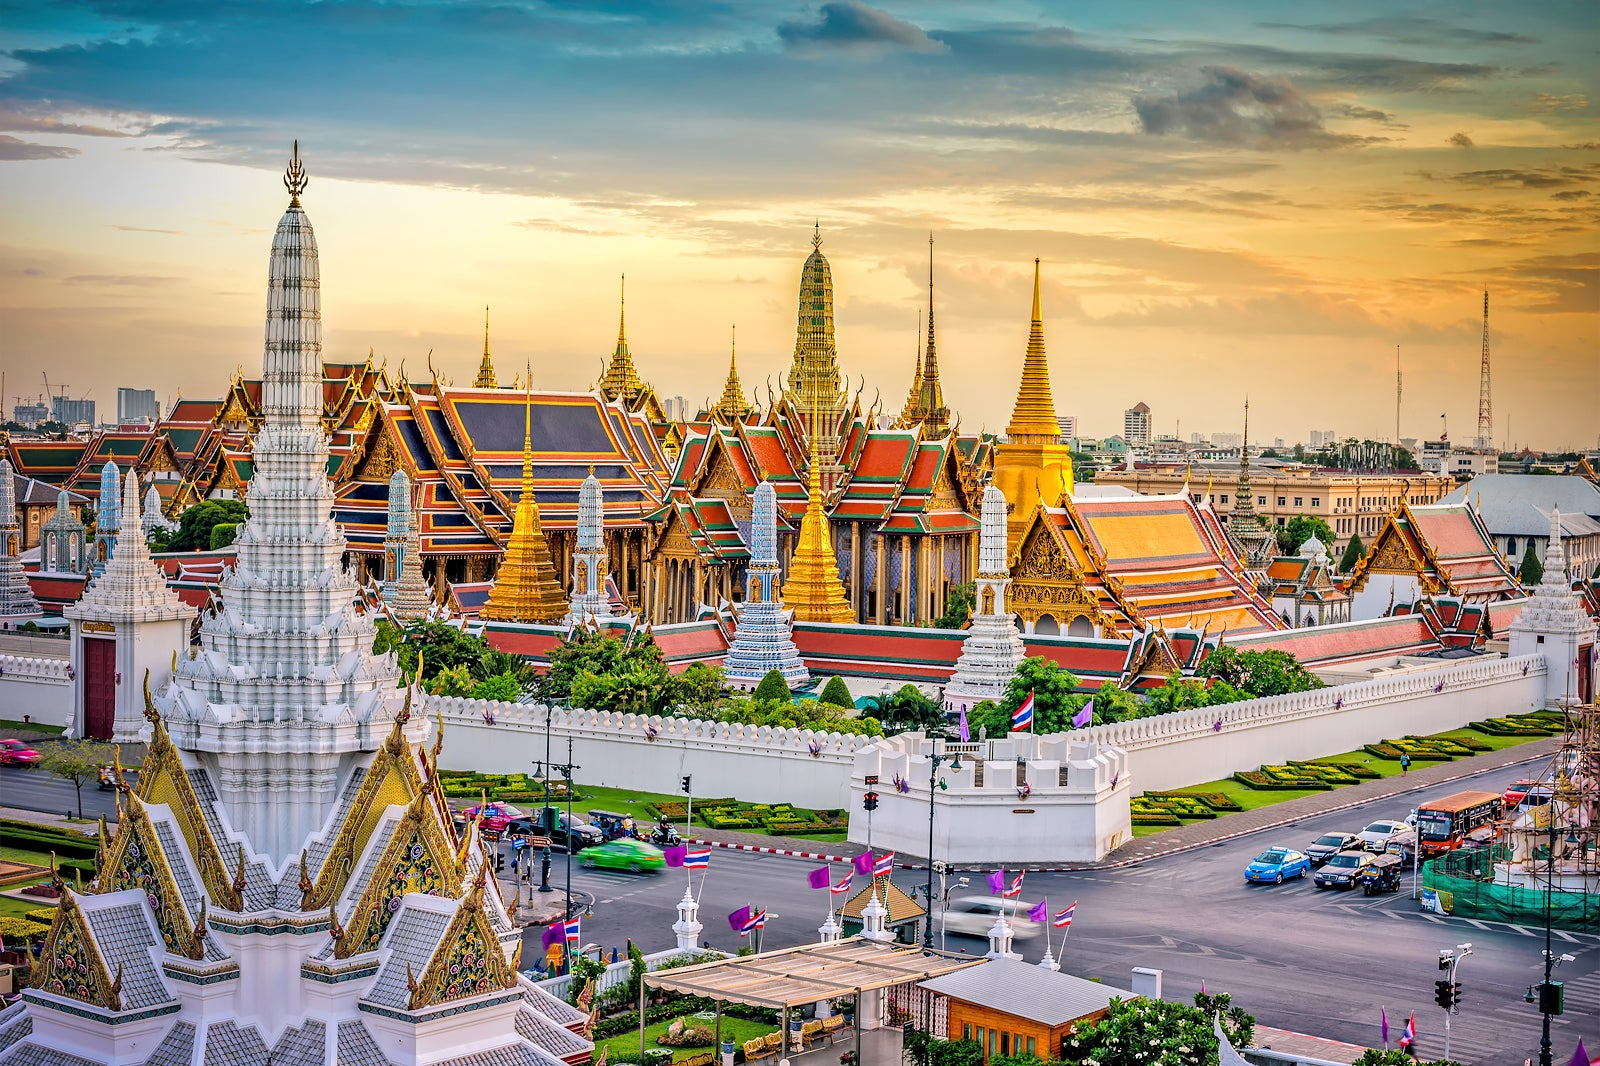Describe the intricate designs on the palace structures. The intricate designs on the palace structures are a testament to traditional Thai craftsmanship. The roofs are covered in vibrant red tiles edged with golden trim and feature meticulous and ornate detailing. Spires and pagodas rise gracefully, adorned with delicate and elaborate carvings that reflect floral patterns, mythical creatures, and religious motifs. Gold leaf and glass mosaics glisten in the sunlight, contributing to a rich and mesmerizing palette of colors. 